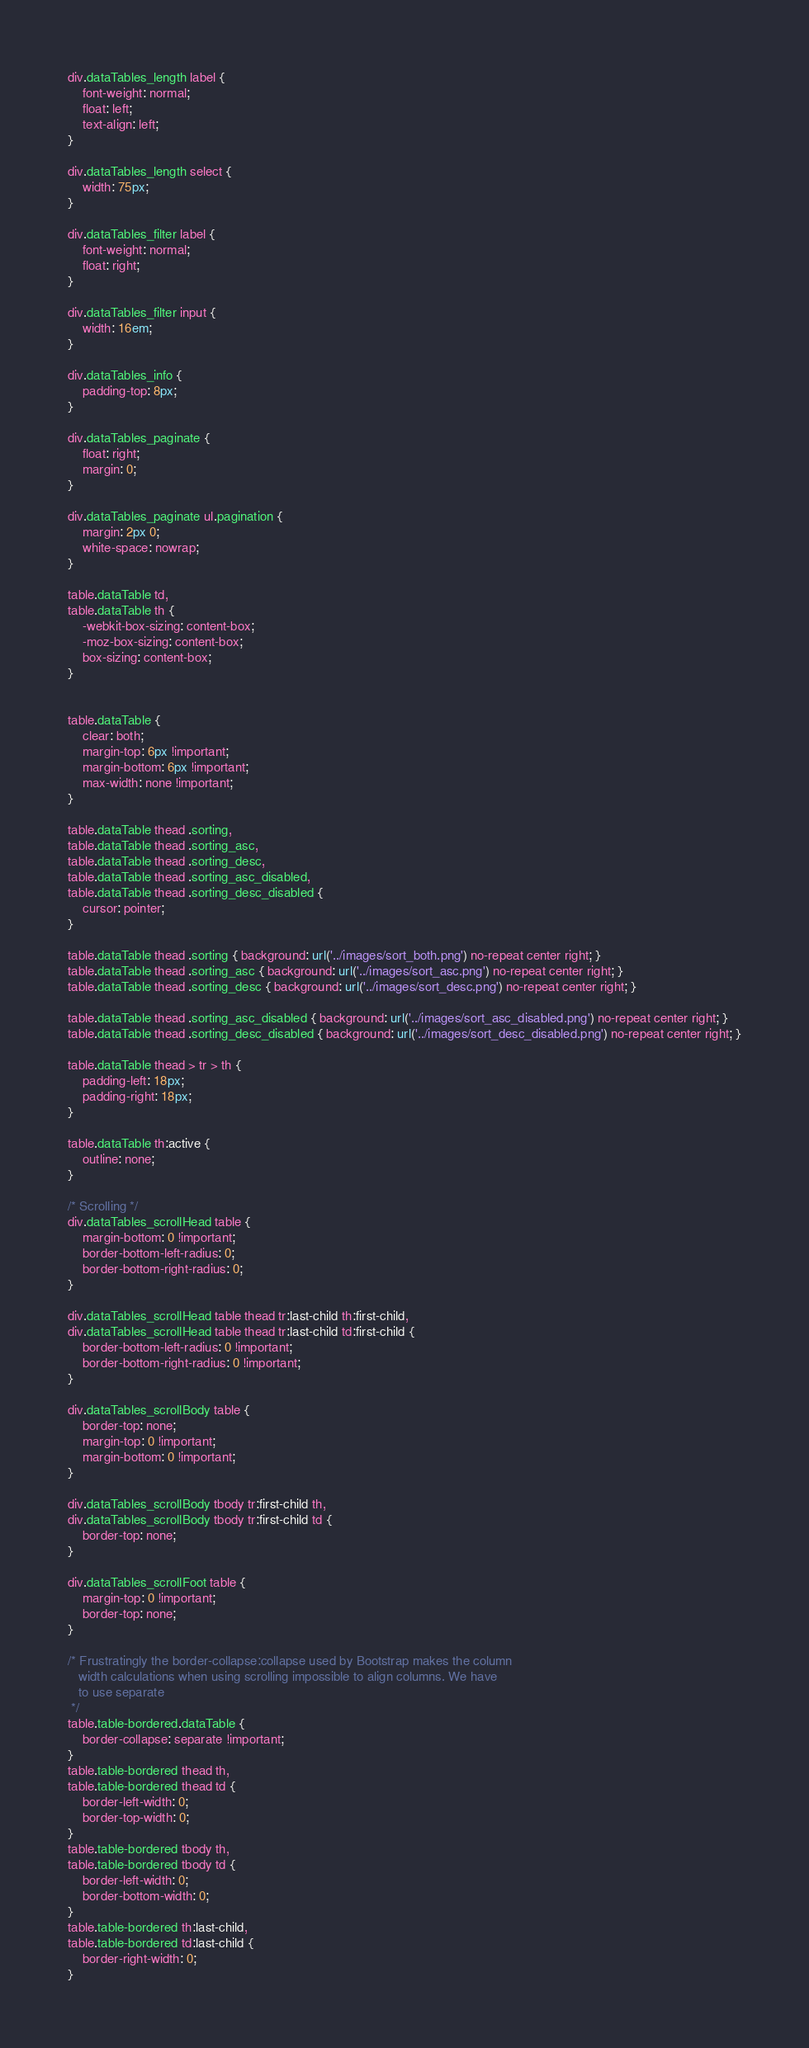Convert code to text. <code><loc_0><loc_0><loc_500><loc_500><_CSS_>div.dataTables_length label {
	font-weight: normal;
	float: left;
	text-align: left;
}

div.dataTables_length select {
	width: 75px;
}

div.dataTables_filter label {
	font-weight: normal;
	float: right;
}

div.dataTables_filter input {
	width: 16em;
}

div.dataTables_info {
	padding-top: 8px;
}

div.dataTables_paginate {
	float: right;
	margin: 0;
}

div.dataTables_paginate ul.pagination {
	margin: 2px 0;
	white-space: nowrap;
}

table.dataTable td,
table.dataTable th {
	-webkit-box-sizing: content-box;
	-moz-box-sizing: content-box;
	box-sizing: content-box;
}


table.dataTable {
	clear: both;
	margin-top: 6px !important;
	margin-bottom: 6px !important;
	max-width: none !important;
}

table.dataTable thead .sorting,
table.dataTable thead .sorting_asc,
table.dataTable thead .sorting_desc,
table.dataTable thead .sorting_asc_disabled,
table.dataTable thead .sorting_desc_disabled {
	cursor: pointer;
}

table.dataTable thead .sorting { background: url('../images/sort_both.png') no-repeat center right; }
table.dataTable thead .sorting_asc { background: url('../images/sort_asc.png') no-repeat center right; }
table.dataTable thead .sorting_desc { background: url('../images/sort_desc.png') no-repeat center right; }

table.dataTable thead .sorting_asc_disabled { background: url('../images/sort_asc_disabled.png') no-repeat center right; }
table.dataTable thead .sorting_desc_disabled { background: url('../images/sort_desc_disabled.png') no-repeat center right; }

table.dataTable thead > tr > th {
	padding-left: 18px;
	padding-right: 18px;
}

table.dataTable th:active {
	outline: none;
}

/* Scrolling */
div.dataTables_scrollHead table {
	margin-bottom: 0 !important;
	border-bottom-left-radius: 0;
	border-bottom-right-radius: 0;
}

div.dataTables_scrollHead table thead tr:last-child th:first-child,
div.dataTables_scrollHead table thead tr:last-child td:first-child {
	border-bottom-left-radius: 0 !important;
	border-bottom-right-radius: 0 !important;
}

div.dataTables_scrollBody table {
	border-top: none;
	margin-top: 0 !important;
	margin-bottom: 0 !important;
}

div.dataTables_scrollBody tbody tr:first-child th,
div.dataTables_scrollBody tbody tr:first-child td {
	border-top: none;
}

div.dataTables_scrollFoot table {
	margin-top: 0 !important;
	border-top: none;
}

/* Frustratingly the border-collapse:collapse used by Bootstrap makes the column
   width calculations when using scrolling impossible to align columns. We have
   to use separate
 */
table.table-bordered.dataTable {
	border-collapse: separate !important;
}
table.table-bordered thead th,
table.table-bordered thead td {
	border-left-width: 0;
	border-top-width: 0;
}
table.table-bordered tbody th,
table.table-bordered tbody td {
	border-left-width: 0;
	border-bottom-width: 0;
}
table.table-bordered th:last-child,
table.table-bordered td:last-child {
	border-right-width: 0;
}</code> 